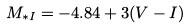Convert formula to latex. <formula><loc_0><loc_0><loc_500><loc_500>M _ { * I } = - 4 . 8 4 + 3 ( V - I )</formula> 